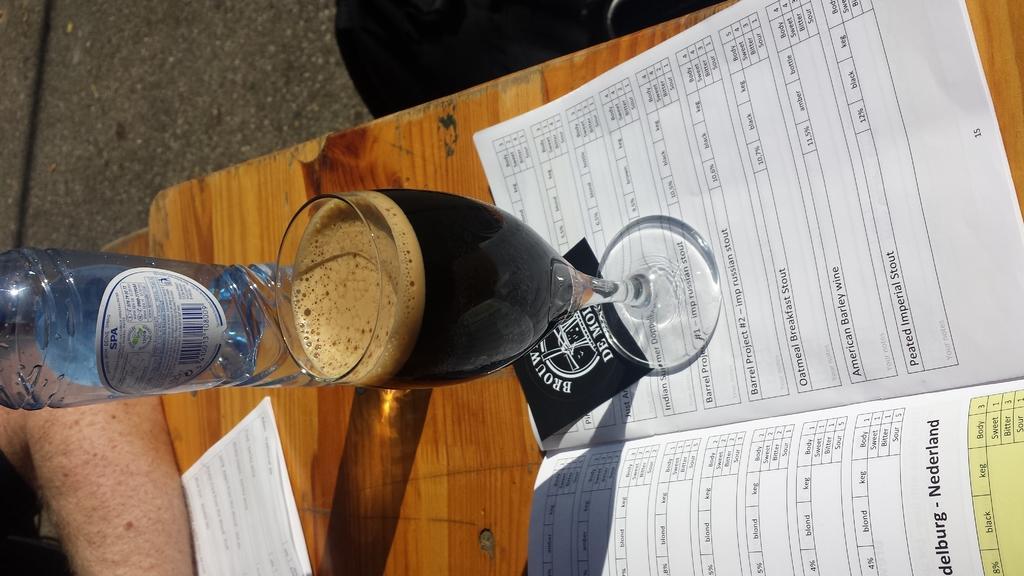In one or two sentences, can you explain what this image depicts? In this image I can see a bottle,glass and a paper. And a sticker is attached to the bottle and these things are on the table. I can see a person's hand on the table. 